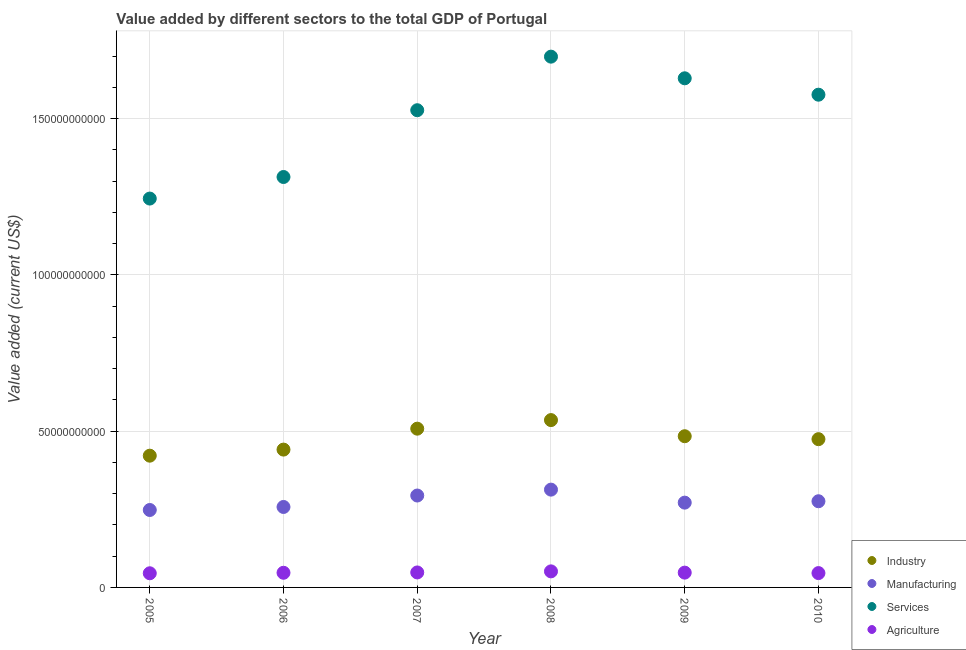Is the number of dotlines equal to the number of legend labels?
Ensure brevity in your answer.  Yes. What is the value added by services sector in 2010?
Your answer should be very brief. 1.58e+11. Across all years, what is the maximum value added by services sector?
Provide a succinct answer. 1.70e+11. Across all years, what is the minimum value added by services sector?
Ensure brevity in your answer.  1.24e+11. In which year was the value added by agricultural sector maximum?
Your response must be concise. 2008. What is the total value added by industrial sector in the graph?
Your answer should be very brief. 2.86e+11. What is the difference between the value added by services sector in 2006 and that in 2007?
Provide a short and direct response. -2.14e+1. What is the difference between the value added by manufacturing sector in 2006 and the value added by industrial sector in 2005?
Keep it short and to the point. -1.64e+1. What is the average value added by manufacturing sector per year?
Offer a very short reply. 2.77e+1. In the year 2010, what is the difference between the value added by industrial sector and value added by manufacturing sector?
Your response must be concise. 1.99e+1. What is the ratio of the value added by manufacturing sector in 2006 to that in 2007?
Your answer should be very brief. 0.88. Is the value added by industrial sector in 2006 less than that in 2010?
Keep it short and to the point. Yes. What is the difference between the highest and the second highest value added by agricultural sector?
Offer a terse response. 3.44e+08. What is the difference between the highest and the lowest value added by agricultural sector?
Offer a very short reply. 6.09e+08. Is the sum of the value added by manufacturing sector in 2006 and 2010 greater than the maximum value added by industrial sector across all years?
Provide a succinct answer. No. Is it the case that in every year, the sum of the value added by industrial sector and value added by manufacturing sector is greater than the value added by services sector?
Give a very brief answer. No. Does the value added by agricultural sector monotonically increase over the years?
Offer a terse response. No. How many dotlines are there?
Your answer should be compact. 4. How many years are there in the graph?
Offer a terse response. 6. What is the difference between two consecutive major ticks on the Y-axis?
Give a very brief answer. 5.00e+1. Are the values on the major ticks of Y-axis written in scientific E-notation?
Keep it short and to the point. No. Does the graph contain any zero values?
Keep it short and to the point. No. How many legend labels are there?
Provide a succinct answer. 4. How are the legend labels stacked?
Give a very brief answer. Vertical. What is the title of the graph?
Ensure brevity in your answer.  Value added by different sectors to the total GDP of Portugal. What is the label or title of the Y-axis?
Provide a succinct answer. Value added (current US$). What is the Value added (current US$) in Industry in 2005?
Your response must be concise. 4.22e+1. What is the Value added (current US$) of Manufacturing in 2005?
Your response must be concise. 2.48e+1. What is the Value added (current US$) of Services in 2005?
Provide a succinct answer. 1.24e+11. What is the Value added (current US$) of Agriculture in 2005?
Your answer should be compact. 4.53e+09. What is the Value added (current US$) in Industry in 2006?
Provide a succinct answer. 4.41e+1. What is the Value added (current US$) in Manufacturing in 2006?
Ensure brevity in your answer.  2.57e+1. What is the Value added (current US$) in Services in 2006?
Make the answer very short. 1.31e+11. What is the Value added (current US$) of Agriculture in 2006?
Keep it short and to the point. 4.69e+09. What is the Value added (current US$) of Industry in 2007?
Your answer should be compact. 5.08e+1. What is the Value added (current US$) of Manufacturing in 2007?
Give a very brief answer. 2.94e+1. What is the Value added (current US$) in Services in 2007?
Make the answer very short. 1.53e+11. What is the Value added (current US$) of Agriculture in 2007?
Keep it short and to the point. 4.79e+09. What is the Value added (current US$) of Industry in 2008?
Offer a very short reply. 5.35e+1. What is the Value added (current US$) in Manufacturing in 2008?
Your answer should be compact. 3.13e+1. What is the Value added (current US$) of Services in 2008?
Your response must be concise. 1.70e+11. What is the Value added (current US$) of Agriculture in 2008?
Offer a very short reply. 5.14e+09. What is the Value added (current US$) in Industry in 2009?
Provide a short and direct response. 4.84e+1. What is the Value added (current US$) of Manufacturing in 2009?
Your response must be concise. 2.71e+1. What is the Value added (current US$) in Services in 2009?
Your answer should be very brief. 1.63e+11. What is the Value added (current US$) of Agriculture in 2009?
Offer a very short reply. 4.74e+09. What is the Value added (current US$) in Industry in 2010?
Make the answer very short. 4.74e+1. What is the Value added (current US$) of Manufacturing in 2010?
Provide a short and direct response. 2.76e+1. What is the Value added (current US$) of Services in 2010?
Provide a short and direct response. 1.58e+11. What is the Value added (current US$) in Agriculture in 2010?
Offer a very short reply. 4.59e+09. Across all years, what is the maximum Value added (current US$) of Industry?
Make the answer very short. 5.35e+1. Across all years, what is the maximum Value added (current US$) in Manufacturing?
Make the answer very short. 3.13e+1. Across all years, what is the maximum Value added (current US$) of Services?
Your answer should be very brief. 1.70e+11. Across all years, what is the maximum Value added (current US$) in Agriculture?
Ensure brevity in your answer.  5.14e+09. Across all years, what is the minimum Value added (current US$) of Industry?
Make the answer very short. 4.22e+1. Across all years, what is the minimum Value added (current US$) in Manufacturing?
Offer a very short reply. 2.48e+1. Across all years, what is the minimum Value added (current US$) in Services?
Offer a very short reply. 1.24e+11. Across all years, what is the minimum Value added (current US$) in Agriculture?
Provide a short and direct response. 4.53e+09. What is the total Value added (current US$) of Industry in the graph?
Provide a short and direct response. 2.86e+11. What is the total Value added (current US$) of Manufacturing in the graph?
Your answer should be very brief. 1.66e+11. What is the total Value added (current US$) of Services in the graph?
Provide a short and direct response. 8.99e+11. What is the total Value added (current US$) in Agriculture in the graph?
Offer a very short reply. 2.85e+1. What is the difference between the Value added (current US$) in Industry in 2005 and that in 2006?
Ensure brevity in your answer.  -1.95e+09. What is the difference between the Value added (current US$) in Manufacturing in 2005 and that in 2006?
Ensure brevity in your answer.  -9.66e+08. What is the difference between the Value added (current US$) in Services in 2005 and that in 2006?
Your answer should be very brief. -6.90e+09. What is the difference between the Value added (current US$) in Agriculture in 2005 and that in 2006?
Offer a very short reply. -1.59e+08. What is the difference between the Value added (current US$) of Industry in 2005 and that in 2007?
Your response must be concise. -8.64e+09. What is the difference between the Value added (current US$) of Manufacturing in 2005 and that in 2007?
Make the answer very short. -4.63e+09. What is the difference between the Value added (current US$) in Services in 2005 and that in 2007?
Your response must be concise. -2.83e+1. What is the difference between the Value added (current US$) in Agriculture in 2005 and that in 2007?
Your answer should be very brief. -2.64e+08. What is the difference between the Value added (current US$) in Industry in 2005 and that in 2008?
Make the answer very short. -1.14e+1. What is the difference between the Value added (current US$) in Manufacturing in 2005 and that in 2008?
Your answer should be compact. -6.52e+09. What is the difference between the Value added (current US$) of Services in 2005 and that in 2008?
Give a very brief answer. -4.54e+1. What is the difference between the Value added (current US$) in Agriculture in 2005 and that in 2008?
Make the answer very short. -6.09e+08. What is the difference between the Value added (current US$) in Industry in 2005 and that in 2009?
Your answer should be compact. -6.23e+09. What is the difference between the Value added (current US$) in Manufacturing in 2005 and that in 2009?
Keep it short and to the point. -2.35e+09. What is the difference between the Value added (current US$) in Services in 2005 and that in 2009?
Provide a succinct answer. -3.85e+1. What is the difference between the Value added (current US$) of Agriculture in 2005 and that in 2009?
Provide a succinct answer. -2.07e+08. What is the difference between the Value added (current US$) of Industry in 2005 and that in 2010?
Give a very brief answer. -5.28e+09. What is the difference between the Value added (current US$) in Manufacturing in 2005 and that in 2010?
Keep it short and to the point. -2.80e+09. What is the difference between the Value added (current US$) of Services in 2005 and that in 2010?
Ensure brevity in your answer.  -3.32e+1. What is the difference between the Value added (current US$) of Agriculture in 2005 and that in 2010?
Your answer should be very brief. -5.83e+07. What is the difference between the Value added (current US$) of Industry in 2006 and that in 2007?
Your answer should be compact. -6.70e+09. What is the difference between the Value added (current US$) of Manufacturing in 2006 and that in 2007?
Your answer should be very brief. -3.66e+09. What is the difference between the Value added (current US$) of Services in 2006 and that in 2007?
Offer a terse response. -2.14e+1. What is the difference between the Value added (current US$) of Agriculture in 2006 and that in 2007?
Your answer should be compact. -1.05e+08. What is the difference between the Value added (current US$) in Industry in 2006 and that in 2008?
Make the answer very short. -9.44e+09. What is the difference between the Value added (current US$) of Manufacturing in 2006 and that in 2008?
Give a very brief answer. -5.55e+09. What is the difference between the Value added (current US$) in Services in 2006 and that in 2008?
Make the answer very short. -3.85e+1. What is the difference between the Value added (current US$) in Agriculture in 2006 and that in 2008?
Your answer should be compact. -4.49e+08. What is the difference between the Value added (current US$) in Industry in 2006 and that in 2009?
Give a very brief answer. -4.28e+09. What is the difference between the Value added (current US$) in Manufacturing in 2006 and that in 2009?
Your response must be concise. -1.39e+09. What is the difference between the Value added (current US$) of Services in 2006 and that in 2009?
Keep it short and to the point. -3.16e+1. What is the difference between the Value added (current US$) in Agriculture in 2006 and that in 2009?
Give a very brief answer. -4.78e+07. What is the difference between the Value added (current US$) of Industry in 2006 and that in 2010?
Your answer should be compact. -3.34e+09. What is the difference between the Value added (current US$) in Manufacturing in 2006 and that in 2010?
Keep it short and to the point. -1.83e+09. What is the difference between the Value added (current US$) of Services in 2006 and that in 2010?
Offer a very short reply. -2.63e+1. What is the difference between the Value added (current US$) of Agriculture in 2006 and that in 2010?
Make the answer very short. 1.01e+08. What is the difference between the Value added (current US$) in Industry in 2007 and that in 2008?
Provide a succinct answer. -2.75e+09. What is the difference between the Value added (current US$) of Manufacturing in 2007 and that in 2008?
Your answer should be very brief. -1.89e+09. What is the difference between the Value added (current US$) of Services in 2007 and that in 2008?
Provide a succinct answer. -1.71e+1. What is the difference between the Value added (current US$) of Agriculture in 2007 and that in 2008?
Keep it short and to the point. -3.44e+08. What is the difference between the Value added (current US$) of Industry in 2007 and that in 2009?
Offer a very short reply. 2.42e+09. What is the difference between the Value added (current US$) in Manufacturing in 2007 and that in 2009?
Ensure brevity in your answer.  2.28e+09. What is the difference between the Value added (current US$) in Services in 2007 and that in 2009?
Make the answer very short. -1.02e+1. What is the difference between the Value added (current US$) of Agriculture in 2007 and that in 2009?
Offer a terse response. 5.74e+07. What is the difference between the Value added (current US$) of Industry in 2007 and that in 2010?
Offer a very short reply. 3.36e+09. What is the difference between the Value added (current US$) of Manufacturing in 2007 and that in 2010?
Ensure brevity in your answer.  1.83e+09. What is the difference between the Value added (current US$) in Services in 2007 and that in 2010?
Your response must be concise. -4.97e+09. What is the difference between the Value added (current US$) of Agriculture in 2007 and that in 2010?
Offer a very short reply. 2.06e+08. What is the difference between the Value added (current US$) in Industry in 2008 and that in 2009?
Make the answer very short. 5.16e+09. What is the difference between the Value added (current US$) in Manufacturing in 2008 and that in 2009?
Offer a very short reply. 4.16e+09. What is the difference between the Value added (current US$) of Services in 2008 and that in 2009?
Give a very brief answer. 6.93e+09. What is the difference between the Value added (current US$) in Agriculture in 2008 and that in 2009?
Ensure brevity in your answer.  4.02e+08. What is the difference between the Value added (current US$) in Industry in 2008 and that in 2010?
Offer a terse response. 6.10e+09. What is the difference between the Value added (current US$) in Manufacturing in 2008 and that in 2010?
Your response must be concise. 3.72e+09. What is the difference between the Value added (current US$) of Services in 2008 and that in 2010?
Your answer should be very brief. 1.22e+1. What is the difference between the Value added (current US$) of Agriculture in 2008 and that in 2010?
Provide a short and direct response. 5.50e+08. What is the difference between the Value added (current US$) in Industry in 2009 and that in 2010?
Your answer should be very brief. 9.42e+08. What is the difference between the Value added (current US$) of Manufacturing in 2009 and that in 2010?
Provide a short and direct response. -4.47e+08. What is the difference between the Value added (current US$) in Services in 2009 and that in 2010?
Provide a succinct answer. 5.25e+09. What is the difference between the Value added (current US$) in Agriculture in 2009 and that in 2010?
Ensure brevity in your answer.  1.49e+08. What is the difference between the Value added (current US$) of Industry in 2005 and the Value added (current US$) of Manufacturing in 2006?
Your answer should be very brief. 1.64e+1. What is the difference between the Value added (current US$) of Industry in 2005 and the Value added (current US$) of Services in 2006?
Provide a short and direct response. -8.92e+1. What is the difference between the Value added (current US$) of Industry in 2005 and the Value added (current US$) of Agriculture in 2006?
Make the answer very short. 3.75e+1. What is the difference between the Value added (current US$) of Manufacturing in 2005 and the Value added (current US$) of Services in 2006?
Give a very brief answer. -1.07e+11. What is the difference between the Value added (current US$) of Manufacturing in 2005 and the Value added (current US$) of Agriculture in 2006?
Make the answer very short. 2.01e+1. What is the difference between the Value added (current US$) in Services in 2005 and the Value added (current US$) in Agriculture in 2006?
Offer a very short reply. 1.20e+11. What is the difference between the Value added (current US$) of Industry in 2005 and the Value added (current US$) of Manufacturing in 2007?
Offer a terse response. 1.28e+1. What is the difference between the Value added (current US$) in Industry in 2005 and the Value added (current US$) in Services in 2007?
Give a very brief answer. -1.11e+11. What is the difference between the Value added (current US$) of Industry in 2005 and the Value added (current US$) of Agriculture in 2007?
Give a very brief answer. 3.74e+1. What is the difference between the Value added (current US$) in Manufacturing in 2005 and the Value added (current US$) in Services in 2007?
Give a very brief answer. -1.28e+11. What is the difference between the Value added (current US$) of Manufacturing in 2005 and the Value added (current US$) of Agriculture in 2007?
Provide a short and direct response. 2.00e+1. What is the difference between the Value added (current US$) of Services in 2005 and the Value added (current US$) of Agriculture in 2007?
Provide a succinct answer. 1.20e+11. What is the difference between the Value added (current US$) of Industry in 2005 and the Value added (current US$) of Manufacturing in 2008?
Your answer should be compact. 1.09e+1. What is the difference between the Value added (current US$) of Industry in 2005 and the Value added (current US$) of Services in 2008?
Make the answer very short. -1.28e+11. What is the difference between the Value added (current US$) in Industry in 2005 and the Value added (current US$) in Agriculture in 2008?
Provide a short and direct response. 3.70e+1. What is the difference between the Value added (current US$) in Manufacturing in 2005 and the Value added (current US$) in Services in 2008?
Offer a very short reply. -1.45e+11. What is the difference between the Value added (current US$) of Manufacturing in 2005 and the Value added (current US$) of Agriculture in 2008?
Your answer should be compact. 1.96e+1. What is the difference between the Value added (current US$) in Services in 2005 and the Value added (current US$) in Agriculture in 2008?
Make the answer very short. 1.19e+11. What is the difference between the Value added (current US$) in Industry in 2005 and the Value added (current US$) in Manufacturing in 2009?
Offer a terse response. 1.50e+1. What is the difference between the Value added (current US$) of Industry in 2005 and the Value added (current US$) of Services in 2009?
Offer a terse response. -1.21e+11. What is the difference between the Value added (current US$) in Industry in 2005 and the Value added (current US$) in Agriculture in 2009?
Give a very brief answer. 3.74e+1. What is the difference between the Value added (current US$) of Manufacturing in 2005 and the Value added (current US$) of Services in 2009?
Offer a terse response. -1.38e+11. What is the difference between the Value added (current US$) in Manufacturing in 2005 and the Value added (current US$) in Agriculture in 2009?
Your answer should be very brief. 2.00e+1. What is the difference between the Value added (current US$) in Services in 2005 and the Value added (current US$) in Agriculture in 2009?
Keep it short and to the point. 1.20e+11. What is the difference between the Value added (current US$) in Industry in 2005 and the Value added (current US$) in Manufacturing in 2010?
Keep it short and to the point. 1.46e+1. What is the difference between the Value added (current US$) in Industry in 2005 and the Value added (current US$) in Services in 2010?
Provide a succinct answer. -1.16e+11. What is the difference between the Value added (current US$) in Industry in 2005 and the Value added (current US$) in Agriculture in 2010?
Provide a succinct answer. 3.76e+1. What is the difference between the Value added (current US$) in Manufacturing in 2005 and the Value added (current US$) in Services in 2010?
Provide a succinct answer. -1.33e+11. What is the difference between the Value added (current US$) of Manufacturing in 2005 and the Value added (current US$) of Agriculture in 2010?
Your response must be concise. 2.02e+1. What is the difference between the Value added (current US$) in Services in 2005 and the Value added (current US$) in Agriculture in 2010?
Your answer should be compact. 1.20e+11. What is the difference between the Value added (current US$) of Industry in 2006 and the Value added (current US$) of Manufacturing in 2007?
Your answer should be very brief. 1.47e+1. What is the difference between the Value added (current US$) in Industry in 2006 and the Value added (current US$) in Services in 2007?
Your response must be concise. -1.09e+11. What is the difference between the Value added (current US$) in Industry in 2006 and the Value added (current US$) in Agriculture in 2007?
Your response must be concise. 3.93e+1. What is the difference between the Value added (current US$) of Manufacturing in 2006 and the Value added (current US$) of Services in 2007?
Your answer should be very brief. -1.27e+11. What is the difference between the Value added (current US$) of Manufacturing in 2006 and the Value added (current US$) of Agriculture in 2007?
Keep it short and to the point. 2.10e+1. What is the difference between the Value added (current US$) in Services in 2006 and the Value added (current US$) in Agriculture in 2007?
Keep it short and to the point. 1.27e+11. What is the difference between the Value added (current US$) of Industry in 2006 and the Value added (current US$) of Manufacturing in 2008?
Offer a very short reply. 1.28e+1. What is the difference between the Value added (current US$) in Industry in 2006 and the Value added (current US$) in Services in 2008?
Give a very brief answer. -1.26e+11. What is the difference between the Value added (current US$) in Industry in 2006 and the Value added (current US$) in Agriculture in 2008?
Ensure brevity in your answer.  3.90e+1. What is the difference between the Value added (current US$) of Manufacturing in 2006 and the Value added (current US$) of Services in 2008?
Ensure brevity in your answer.  -1.44e+11. What is the difference between the Value added (current US$) in Manufacturing in 2006 and the Value added (current US$) in Agriculture in 2008?
Ensure brevity in your answer.  2.06e+1. What is the difference between the Value added (current US$) in Services in 2006 and the Value added (current US$) in Agriculture in 2008?
Keep it short and to the point. 1.26e+11. What is the difference between the Value added (current US$) in Industry in 2006 and the Value added (current US$) in Manufacturing in 2009?
Your answer should be very brief. 1.70e+1. What is the difference between the Value added (current US$) in Industry in 2006 and the Value added (current US$) in Services in 2009?
Ensure brevity in your answer.  -1.19e+11. What is the difference between the Value added (current US$) in Industry in 2006 and the Value added (current US$) in Agriculture in 2009?
Give a very brief answer. 3.94e+1. What is the difference between the Value added (current US$) in Manufacturing in 2006 and the Value added (current US$) in Services in 2009?
Provide a short and direct response. -1.37e+11. What is the difference between the Value added (current US$) in Manufacturing in 2006 and the Value added (current US$) in Agriculture in 2009?
Give a very brief answer. 2.10e+1. What is the difference between the Value added (current US$) in Services in 2006 and the Value added (current US$) in Agriculture in 2009?
Keep it short and to the point. 1.27e+11. What is the difference between the Value added (current US$) of Industry in 2006 and the Value added (current US$) of Manufacturing in 2010?
Make the answer very short. 1.65e+1. What is the difference between the Value added (current US$) of Industry in 2006 and the Value added (current US$) of Services in 2010?
Your answer should be compact. -1.14e+11. What is the difference between the Value added (current US$) in Industry in 2006 and the Value added (current US$) in Agriculture in 2010?
Your answer should be very brief. 3.95e+1. What is the difference between the Value added (current US$) of Manufacturing in 2006 and the Value added (current US$) of Services in 2010?
Your response must be concise. -1.32e+11. What is the difference between the Value added (current US$) of Manufacturing in 2006 and the Value added (current US$) of Agriculture in 2010?
Your response must be concise. 2.12e+1. What is the difference between the Value added (current US$) of Services in 2006 and the Value added (current US$) of Agriculture in 2010?
Your response must be concise. 1.27e+11. What is the difference between the Value added (current US$) in Industry in 2007 and the Value added (current US$) in Manufacturing in 2008?
Provide a succinct answer. 1.95e+1. What is the difference between the Value added (current US$) of Industry in 2007 and the Value added (current US$) of Services in 2008?
Your answer should be very brief. -1.19e+11. What is the difference between the Value added (current US$) of Industry in 2007 and the Value added (current US$) of Agriculture in 2008?
Keep it short and to the point. 4.57e+1. What is the difference between the Value added (current US$) in Manufacturing in 2007 and the Value added (current US$) in Services in 2008?
Provide a short and direct response. -1.40e+11. What is the difference between the Value added (current US$) of Manufacturing in 2007 and the Value added (current US$) of Agriculture in 2008?
Give a very brief answer. 2.43e+1. What is the difference between the Value added (current US$) in Services in 2007 and the Value added (current US$) in Agriculture in 2008?
Your answer should be very brief. 1.48e+11. What is the difference between the Value added (current US$) of Industry in 2007 and the Value added (current US$) of Manufacturing in 2009?
Provide a succinct answer. 2.37e+1. What is the difference between the Value added (current US$) in Industry in 2007 and the Value added (current US$) in Services in 2009?
Make the answer very short. -1.12e+11. What is the difference between the Value added (current US$) of Industry in 2007 and the Value added (current US$) of Agriculture in 2009?
Offer a terse response. 4.61e+1. What is the difference between the Value added (current US$) of Manufacturing in 2007 and the Value added (current US$) of Services in 2009?
Your answer should be compact. -1.34e+11. What is the difference between the Value added (current US$) in Manufacturing in 2007 and the Value added (current US$) in Agriculture in 2009?
Provide a short and direct response. 2.47e+1. What is the difference between the Value added (current US$) of Services in 2007 and the Value added (current US$) of Agriculture in 2009?
Offer a very short reply. 1.48e+11. What is the difference between the Value added (current US$) of Industry in 2007 and the Value added (current US$) of Manufacturing in 2010?
Give a very brief answer. 2.32e+1. What is the difference between the Value added (current US$) in Industry in 2007 and the Value added (current US$) in Services in 2010?
Give a very brief answer. -1.07e+11. What is the difference between the Value added (current US$) of Industry in 2007 and the Value added (current US$) of Agriculture in 2010?
Provide a short and direct response. 4.62e+1. What is the difference between the Value added (current US$) in Manufacturing in 2007 and the Value added (current US$) in Services in 2010?
Give a very brief answer. -1.28e+11. What is the difference between the Value added (current US$) in Manufacturing in 2007 and the Value added (current US$) in Agriculture in 2010?
Give a very brief answer. 2.48e+1. What is the difference between the Value added (current US$) in Services in 2007 and the Value added (current US$) in Agriculture in 2010?
Ensure brevity in your answer.  1.48e+11. What is the difference between the Value added (current US$) in Industry in 2008 and the Value added (current US$) in Manufacturing in 2009?
Your answer should be compact. 2.64e+1. What is the difference between the Value added (current US$) in Industry in 2008 and the Value added (current US$) in Services in 2009?
Provide a succinct answer. -1.09e+11. What is the difference between the Value added (current US$) in Industry in 2008 and the Value added (current US$) in Agriculture in 2009?
Make the answer very short. 4.88e+1. What is the difference between the Value added (current US$) of Manufacturing in 2008 and the Value added (current US$) of Services in 2009?
Offer a terse response. -1.32e+11. What is the difference between the Value added (current US$) in Manufacturing in 2008 and the Value added (current US$) in Agriculture in 2009?
Make the answer very short. 2.66e+1. What is the difference between the Value added (current US$) in Services in 2008 and the Value added (current US$) in Agriculture in 2009?
Offer a terse response. 1.65e+11. What is the difference between the Value added (current US$) of Industry in 2008 and the Value added (current US$) of Manufacturing in 2010?
Provide a short and direct response. 2.60e+1. What is the difference between the Value added (current US$) of Industry in 2008 and the Value added (current US$) of Services in 2010?
Your response must be concise. -1.04e+11. What is the difference between the Value added (current US$) in Industry in 2008 and the Value added (current US$) in Agriculture in 2010?
Provide a short and direct response. 4.90e+1. What is the difference between the Value added (current US$) in Manufacturing in 2008 and the Value added (current US$) in Services in 2010?
Make the answer very short. -1.26e+11. What is the difference between the Value added (current US$) of Manufacturing in 2008 and the Value added (current US$) of Agriculture in 2010?
Provide a short and direct response. 2.67e+1. What is the difference between the Value added (current US$) of Services in 2008 and the Value added (current US$) of Agriculture in 2010?
Give a very brief answer. 1.65e+11. What is the difference between the Value added (current US$) of Industry in 2009 and the Value added (current US$) of Manufacturing in 2010?
Make the answer very short. 2.08e+1. What is the difference between the Value added (current US$) in Industry in 2009 and the Value added (current US$) in Services in 2010?
Provide a succinct answer. -1.09e+11. What is the difference between the Value added (current US$) in Industry in 2009 and the Value added (current US$) in Agriculture in 2010?
Provide a succinct answer. 4.38e+1. What is the difference between the Value added (current US$) in Manufacturing in 2009 and the Value added (current US$) in Services in 2010?
Your answer should be compact. -1.31e+11. What is the difference between the Value added (current US$) of Manufacturing in 2009 and the Value added (current US$) of Agriculture in 2010?
Offer a terse response. 2.25e+1. What is the difference between the Value added (current US$) in Services in 2009 and the Value added (current US$) in Agriculture in 2010?
Your response must be concise. 1.58e+11. What is the average Value added (current US$) in Industry per year?
Give a very brief answer. 4.77e+1. What is the average Value added (current US$) of Manufacturing per year?
Your answer should be very brief. 2.77e+1. What is the average Value added (current US$) of Services per year?
Provide a short and direct response. 1.50e+11. What is the average Value added (current US$) of Agriculture per year?
Your answer should be compact. 4.75e+09. In the year 2005, what is the difference between the Value added (current US$) of Industry and Value added (current US$) of Manufacturing?
Provide a short and direct response. 1.74e+1. In the year 2005, what is the difference between the Value added (current US$) in Industry and Value added (current US$) in Services?
Make the answer very short. -8.23e+1. In the year 2005, what is the difference between the Value added (current US$) of Industry and Value added (current US$) of Agriculture?
Keep it short and to the point. 3.76e+1. In the year 2005, what is the difference between the Value added (current US$) in Manufacturing and Value added (current US$) in Services?
Keep it short and to the point. -9.97e+1. In the year 2005, what is the difference between the Value added (current US$) of Manufacturing and Value added (current US$) of Agriculture?
Provide a succinct answer. 2.03e+1. In the year 2005, what is the difference between the Value added (current US$) of Services and Value added (current US$) of Agriculture?
Your answer should be very brief. 1.20e+11. In the year 2006, what is the difference between the Value added (current US$) of Industry and Value added (current US$) of Manufacturing?
Your answer should be very brief. 1.84e+1. In the year 2006, what is the difference between the Value added (current US$) of Industry and Value added (current US$) of Services?
Keep it short and to the point. -8.72e+1. In the year 2006, what is the difference between the Value added (current US$) in Industry and Value added (current US$) in Agriculture?
Provide a short and direct response. 3.94e+1. In the year 2006, what is the difference between the Value added (current US$) in Manufacturing and Value added (current US$) in Services?
Give a very brief answer. -1.06e+11. In the year 2006, what is the difference between the Value added (current US$) in Manufacturing and Value added (current US$) in Agriculture?
Provide a succinct answer. 2.11e+1. In the year 2006, what is the difference between the Value added (current US$) in Services and Value added (current US$) in Agriculture?
Provide a short and direct response. 1.27e+11. In the year 2007, what is the difference between the Value added (current US$) in Industry and Value added (current US$) in Manufacturing?
Your response must be concise. 2.14e+1. In the year 2007, what is the difference between the Value added (current US$) in Industry and Value added (current US$) in Services?
Keep it short and to the point. -1.02e+11. In the year 2007, what is the difference between the Value added (current US$) of Industry and Value added (current US$) of Agriculture?
Provide a succinct answer. 4.60e+1. In the year 2007, what is the difference between the Value added (current US$) of Manufacturing and Value added (current US$) of Services?
Make the answer very short. -1.23e+11. In the year 2007, what is the difference between the Value added (current US$) of Manufacturing and Value added (current US$) of Agriculture?
Keep it short and to the point. 2.46e+1. In the year 2007, what is the difference between the Value added (current US$) of Services and Value added (current US$) of Agriculture?
Keep it short and to the point. 1.48e+11. In the year 2008, what is the difference between the Value added (current US$) in Industry and Value added (current US$) in Manufacturing?
Your answer should be compact. 2.23e+1. In the year 2008, what is the difference between the Value added (current US$) in Industry and Value added (current US$) in Services?
Give a very brief answer. -1.16e+11. In the year 2008, what is the difference between the Value added (current US$) of Industry and Value added (current US$) of Agriculture?
Offer a very short reply. 4.84e+1. In the year 2008, what is the difference between the Value added (current US$) of Manufacturing and Value added (current US$) of Services?
Make the answer very short. -1.39e+11. In the year 2008, what is the difference between the Value added (current US$) in Manufacturing and Value added (current US$) in Agriculture?
Keep it short and to the point. 2.62e+1. In the year 2008, what is the difference between the Value added (current US$) in Services and Value added (current US$) in Agriculture?
Keep it short and to the point. 1.65e+11. In the year 2009, what is the difference between the Value added (current US$) of Industry and Value added (current US$) of Manufacturing?
Keep it short and to the point. 2.13e+1. In the year 2009, what is the difference between the Value added (current US$) of Industry and Value added (current US$) of Services?
Offer a terse response. -1.15e+11. In the year 2009, what is the difference between the Value added (current US$) in Industry and Value added (current US$) in Agriculture?
Make the answer very short. 4.36e+1. In the year 2009, what is the difference between the Value added (current US$) in Manufacturing and Value added (current US$) in Services?
Give a very brief answer. -1.36e+11. In the year 2009, what is the difference between the Value added (current US$) in Manufacturing and Value added (current US$) in Agriculture?
Provide a succinct answer. 2.24e+1. In the year 2009, what is the difference between the Value added (current US$) of Services and Value added (current US$) of Agriculture?
Ensure brevity in your answer.  1.58e+11. In the year 2010, what is the difference between the Value added (current US$) of Industry and Value added (current US$) of Manufacturing?
Provide a succinct answer. 1.99e+1. In the year 2010, what is the difference between the Value added (current US$) of Industry and Value added (current US$) of Services?
Your answer should be very brief. -1.10e+11. In the year 2010, what is the difference between the Value added (current US$) of Industry and Value added (current US$) of Agriculture?
Offer a terse response. 4.29e+1. In the year 2010, what is the difference between the Value added (current US$) of Manufacturing and Value added (current US$) of Services?
Your answer should be very brief. -1.30e+11. In the year 2010, what is the difference between the Value added (current US$) in Manufacturing and Value added (current US$) in Agriculture?
Provide a short and direct response. 2.30e+1. In the year 2010, what is the difference between the Value added (current US$) in Services and Value added (current US$) in Agriculture?
Make the answer very short. 1.53e+11. What is the ratio of the Value added (current US$) of Industry in 2005 to that in 2006?
Your response must be concise. 0.96. What is the ratio of the Value added (current US$) of Manufacturing in 2005 to that in 2006?
Provide a succinct answer. 0.96. What is the ratio of the Value added (current US$) in Services in 2005 to that in 2006?
Keep it short and to the point. 0.95. What is the ratio of the Value added (current US$) in Agriculture in 2005 to that in 2006?
Make the answer very short. 0.97. What is the ratio of the Value added (current US$) of Industry in 2005 to that in 2007?
Keep it short and to the point. 0.83. What is the ratio of the Value added (current US$) of Manufacturing in 2005 to that in 2007?
Provide a short and direct response. 0.84. What is the ratio of the Value added (current US$) in Services in 2005 to that in 2007?
Offer a very short reply. 0.81. What is the ratio of the Value added (current US$) of Agriculture in 2005 to that in 2007?
Provide a succinct answer. 0.94. What is the ratio of the Value added (current US$) of Industry in 2005 to that in 2008?
Keep it short and to the point. 0.79. What is the ratio of the Value added (current US$) of Manufacturing in 2005 to that in 2008?
Provide a short and direct response. 0.79. What is the ratio of the Value added (current US$) of Services in 2005 to that in 2008?
Keep it short and to the point. 0.73. What is the ratio of the Value added (current US$) of Agriculture in 2005 to that in 2008?
Provide a succinct answer. 0.88. What is the ratio of the Value added (current US$) of Industry in 2005 to that in 2009?
Ensure brevity in your answer.  0.87. What is the ratio of the Value added (current US$) in Manufacturing in 2005 to that in 2009?
Your answer should be compact. 0.91. What is the ratio of the Value added (current US$) of Services in 2005 to that in 2009?
Ensure brevity in your answer.  0.76. What is the ratio of the Value added (current US$) in Agriculture in 2005 to that in 2009?
Ensure brevity in your answer.  0.96. What is the ratio of the Value added (current US$) in Industry in 2005 to that in 2010?
Your answer should be compact. 0.89. What is the ratio of the Value added (current US$) in Manufacturing in 2005 to that in 2010?
Provide a short and direct response. 0.9. What is the ratio of the Value added (current US$) of Services in 2005 to that in 2010?
Your response must be concise. 0.79. What is the ratio of the Value added (current US$) in Agriculture in 2005 to that in 2010?
Your response must be concise. 0.99. What is the ratio of the Value added (current US$) of Industry in 2006 to that in 2007?
Offer a terse response. 0.87. What is the ratio of the Value added (current US$) of Manufacturing in 2006 to that in 2007?
Your answer should be very brief. 0.88. What is the ratio of the Value added (current US$) of Services in 2006 to that in 2007?
Keep it short and to the point. 0.86. What is the ratio of the Value added (current US$) of Industry in 2006 to that in 2008?
Give a very brief answer. 0.82. What is the ratio of the Value added (current US$) in Manufacturing in 2006 to that in 2008?
Provide a short and direct response. 0.82. What is the ratio of the Value added (current US$) in Services in 2006 to that in 2008?
Your answer should be very brief. 0.77. What is the ratio of the Value added (current US$) in Agriculture in 2006 to that in 2008?
Keep it short and to the point. 0.91. What is the ratio of the Value added (current US$) in Industry in 2006 to that in 2009?
Your response must be concise. 0.91. What is the ratio of the Value added (current US$) of Manufacturing in 2006 to that in 2009?
Your answer should be compact. 0.95. What is the ratio of the Value added (current US$) of Services in 2006 to that in 2009?
Give a very brief answer. 0.81. What is the ratio of the Value added (current US$) in Industry in 2006 to that in 2010?
Offer a very short reply. 0.93. What is the ratio of the Value added (current US$) of Manufacturing in 2006 to that in 2010?
Ensure brevity in your answer.  0.93. What is the ratio of the Value added (current US$) of Services in 2006 to that in 2010?
Give a very brief answer. 0.83. What is the ratio of the Value added (current US$) of Industry in 2007 to that in 2008?
Your response must be concise. 0.95. What is the ratio of the Value added (current US$) of Manufacturing in 2007 to that in 2008?
Keep it short and to the point. 0.94. What is the ratio of the Value added (current US$) in Services in 2007 to that in 2008?
Ensure brevity in your answer.  0.9. What is the ratio of the Value added (current US$) of Agriculture in 2007 to that in 2008?
Make the answer very short. 0.93. What is the ratio of the Value added (current US$) in Industry in 2007 to that in 2009?
Ensure brevity in your answer.  1.05. What is the ratio of the Value added (current US$) in Manufacturing in 2007 to that in 2009?
Give a very brief answer. 1.08. What is the ratio of the Value added (current US$) in Services in 2007 to that in 2009?
Your answer should be very brief. 0.94. What is the ratio of the Value added (current US$) in Agriculture in 2007 to that in 2009?
Give a very brief answer. 1.01. What is the ratio of the Value added (current US$) of Industry in 2007 to that in 2010?
Your answer should be very brief. 1.07. What is the ratio of the Value added (current US$) in Manufacturing in 2007 to that in 2010?
Make the answer very short. 1.07. What is the ratio of the Value added (current US$) of Services in 2007 to that in 2010?
Your answer should be very brief. 0.97. What is the ratio of the Value added (current US$) of Agriculture in 2007 to that in 2010?
Give a very brief answer. 1.04. What is the ratio of the Value added (current US$) in Industry in 2008 to that in 2009?
Offer a very short reply. 1.11. What is the ratio of the Value added (current US$) of Manufacturing in 2008 to that in 2009?
Provide a short and direct response. 1.15. What is the ratio of the Value added (current US$) of Services in 2008 to that in 2009?
Your answer should be compact. 1.04. What is the ratio of the Value added (current US$) in Agriculture in 2008 to that in 2009?
Provide a short and direct response. 1.08. What is the ratio of the Value added (current US$) in Industry in 2008 to that in 2010?
Your response must be concise. 1.13. What is the ratio of the Value added (current US$) in Manufacturing in 2008 to that in 2010?
Offer a terse response. 1.13. What is the ratio of the Value added (current US$) in Services in 2008 to that in 2010?
Your answer should be very brief. 1.08. What is the ratio of the Value added (current US$) in Agriculture in 2008 to that in 2010?
Make the answer very short. 1.12. What is the ratio of the Value added (current US$) in Industry in 2009 to that in 2010?
Keep it short and to the point. 1.02. What is the ratio of the Value added (current US$) of Manufacturing in 2009 to that in 2010?
Provide a short and direct response. 0.98. What is the ratio of the Value added (current US$) in Services in 2009 to that in 2010?
Give a very brief answer. 1.03. What is the ratio of the Value added (current US$) of Agriculture in 2009 to that in 2010?
Make the answer very short. 1.03. What is the difference between the highest and the second highest Value added (current US$) in Industry?
Provide a succinct answer. 2.75e+09. What is the difference between the highest and the second highest Value added (current US$) of Manufacturing?
Make the answer very short. 1.89e+09. What is the difference between the highest and the second highest Value added (current US$) in Services?
Offer a terse response. 6.93e+09. What is the difference between the highest and the second highest Value added (current US$) in Agriculture?
Offer a very short reply. 3.44e+08. What is the difference between the highest and the lowest Value added (current US$) in Industry?
Give a very brief answer. 1.14e+1. What is the difference between the highest and the lowest Value added (current US$) in Manufacturing?
Your response must be concise. 6.52e+09. What is the difference between the highest and the lowest Value added (current US$) in Services?
Keep it short and to the point. 4.54e+1. What is the difference between the highest and the lowest Value added (current US$) in Agriculture?
Your response must be concise. 6.09e+08. 